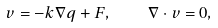<formula> <loc_0><loc_0><loc_500><loc_500>v = - k \nabla q + F , \quad \nabla \cdot v = 0 ,</formula> 